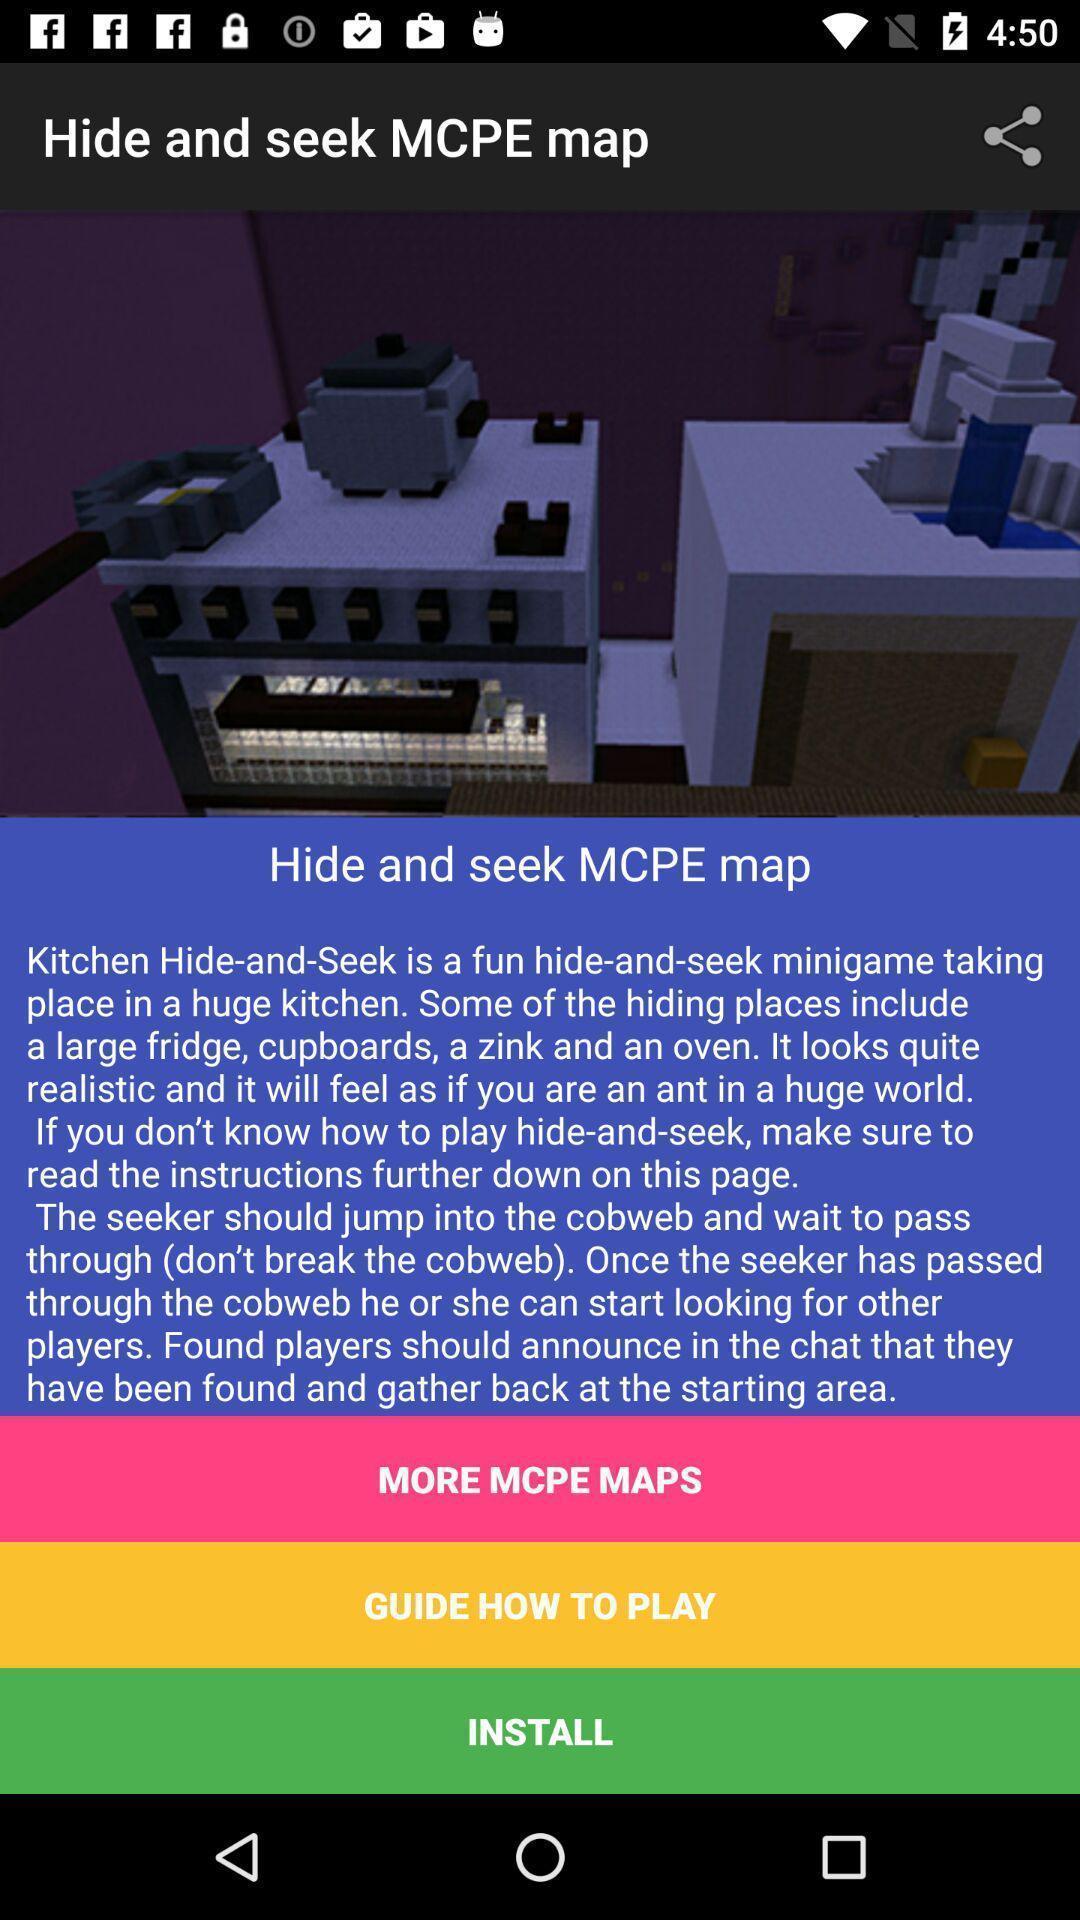Summarize the information in this screenshot. Screen showing description. 